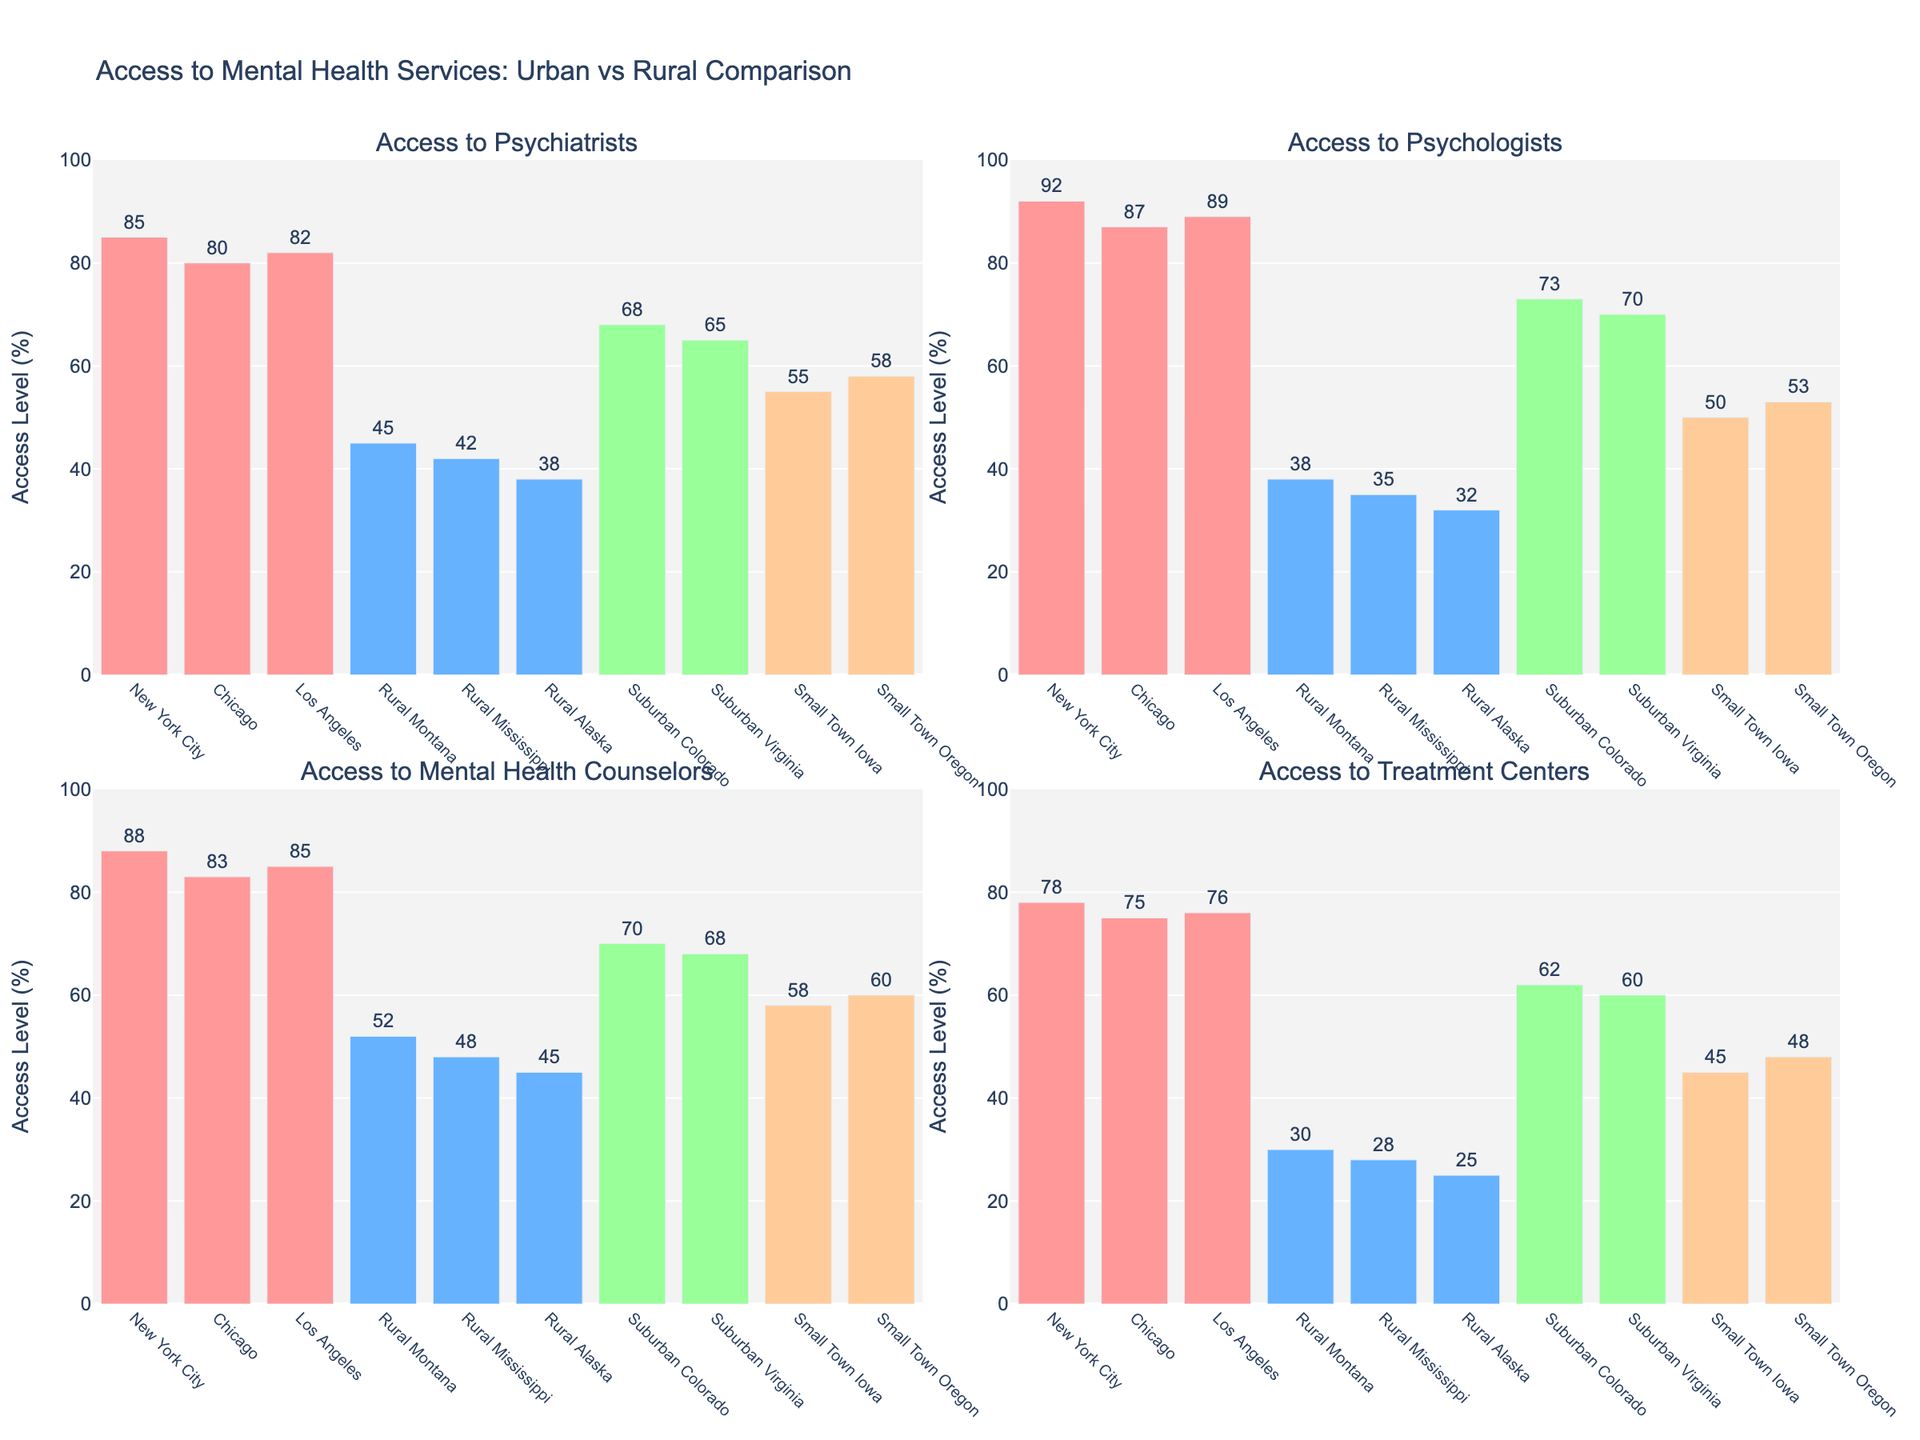Which location has the lowest access to mental health counselors? By examining the heights of the bars associated with “Access to Mental Health Counselors” in each subplot, we see that Rural Alaska has the shortest bar, indicating the lowest access percentage.
Answer: Rural Alaska Which city has the highest level of access to psychologists? Look at the bar heights in the "Access to Psychologists" subplot. New York City has the tallest bar, indicating the highest level of access.
Answer: New York City What is the average access level to treatment centers in suburban areas (Colorado and Virginia)? Add the access percentages for Suburban Colorado (62) and Suburban Virginia (60), then divide by 2 to get the average: (62 + 60) / 2 = 61.
Answer: 61 How much greater is the access to psychiatrists in New York City compared to Rural Alaska? Subtract the access percentage to psychiatrists in Rural Alaska (38) from that in New York City (85): 85 - 38 = 47.
Answer: 47 Which location has the smallest difference in access levels between psychologists and treatment centers? Compare the differences between access percentages for psychologists and treatment centers in all locations. The smallest difference is in New York City, where the difference is 92 - 78 = 14.
Answer: New York City What is the combined access level to mental health services in Small Town Iowa? Sum the access percentages for all four services in Small Town Iowa: 55 (Psychiatrists) + 50 (Psychologists) + 58 (Counselors) + 45 (Treatment Centers) = 208.
Answer: 208 Compare the access to psychologists between Chicago and Rural Mississippi. Chicago has an access percentage of 87 while Rural Mississippi has 35. Calculate how much greater Chicago's access is: 87 - 35 = 52.
Answer: 52 Which service has the most variation in access levels across all locations? By comparing the range (difference between the maximum and minimum values) of each service: Psychiatrists (85 - 38 = 47), Psychologists (92 - 32 = 60), Counselors (88 - 45 = 43), and Treatment Centers (78 - 25 = 53), we see that Access to Psychologists has the most variation (60).
Answer: Access to Psychologists What is the total access level to psychiatrists in the three largest cities combined? Sum the access percentages for psychiatrists in New York City (85), Chicago (80), and Los Angeles (82): 85 + 80 + 82 = 247.
Answer: 247 What is the difference in average access levels between urban and rural areas for all services? Calculate the average access levels for urban areas (New York City, Chicago, Los Angeles) and rural areas (Rural Montana, Rural Mississippi, Rural Alaska), then find the difference. Urban average: [(85+80+82)/3, (92+87+89)/3, (88+83+85)/3, (78+75+76)/3] = [82.33, 89.33, 85.33, 76.33]. Rural average: [(45+42+38)/3, (38+35+32)/3, (52+48+45)/3, (30+28+25)/3] = [41.67, 35, 48.33, 27.67]. Difference for each service is: Psychiatrists (82.33 - 41.67 = 40.66), Psychologists (89.33 - 35 = 54.33), Counselors (85.33 - 48.33 = 37), Treatment Centers (76.33 - 27.67 = 48.66).
Answer: 40.66, 54.33, 37, 48.66 